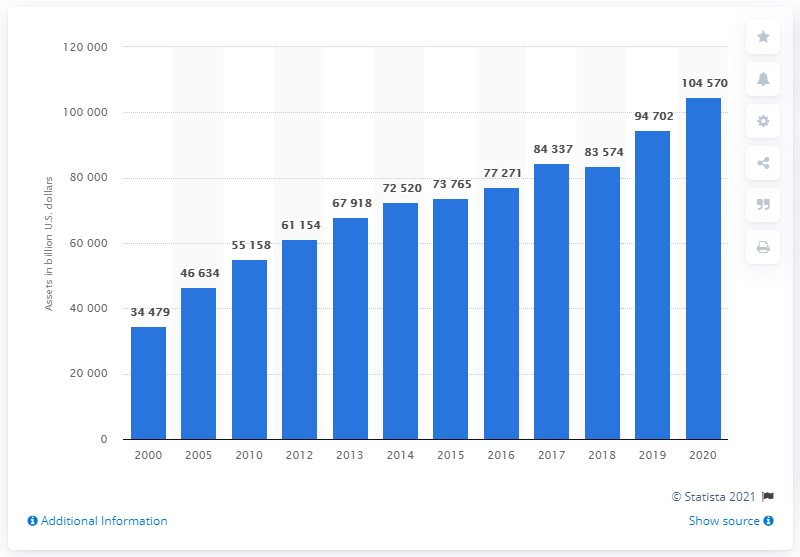Point out several critical features in this image. According to data from 2020, the value of household financial assets was 104,570. In 2000, the value of household financial assets was 34,479. 